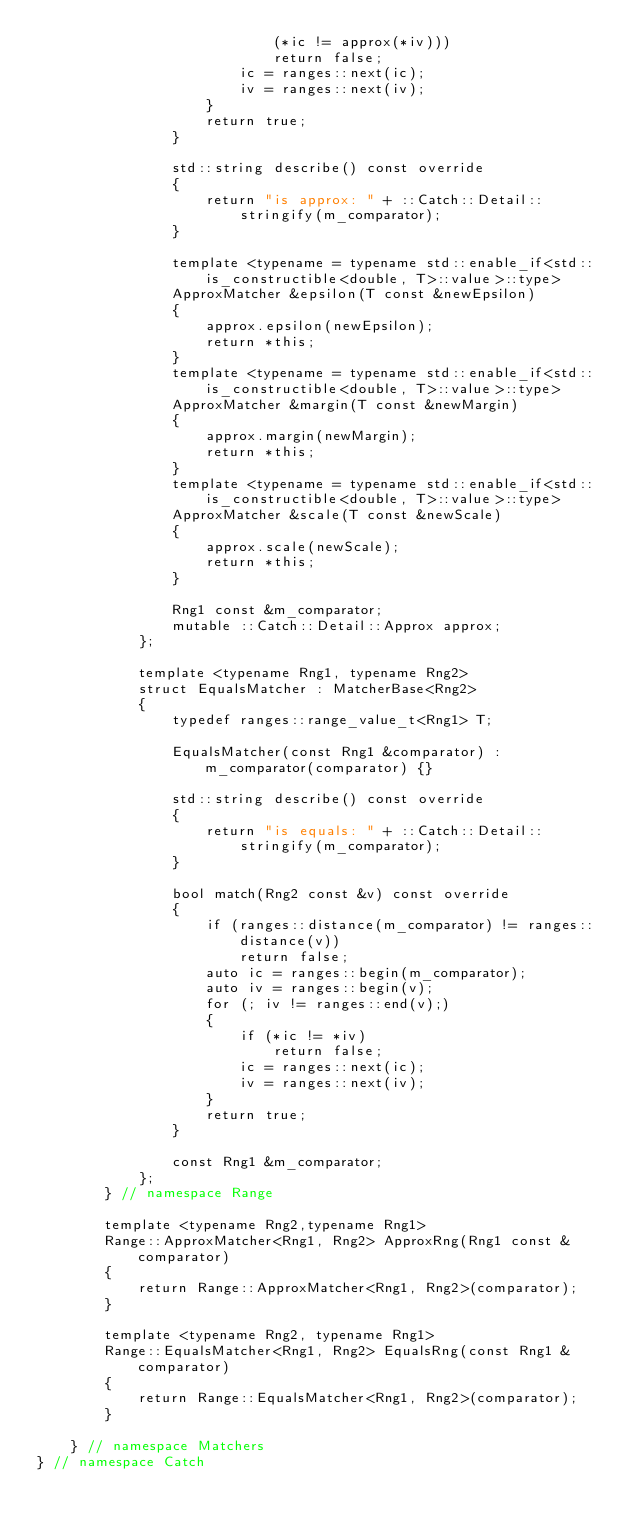Convert code to text. <code><loc_0><loc_0><loc_500><loc_500><_C++_>                            (*ic != approx(*iv)))
                            return false;
                        ic = ranges::next(ic);
                        iv = ranges::next(iv);
                    }
                    return true;
                }

                std::string describe() const override
                {
                    return "is approx: " + ::Catch::Detail::stringify(m_comparator);
                }

                template <typename = typename std::enable_if<std::is_constructible<double, T>::value>::type>
                ApproxMatcher &epsilon(T const &newEpsilon)
                {
                    approx.epsilon(newEpsilon);
                    return *this;
                }
                template <typename = typename std::enable_if<std::is_constructible<double, T>::value>::type>
                ApproxMatcher &margin(T const &newMargin)
                {
                    approx.margin(newMargin);
                    return *this;
                }
                template <typename = typename std::enable_if<std::is_constructible<double, T>::value>::type>
                ApproxMatcher &scale(T const &newScale)
                {
                    approx.scale(newScale);
                    return *this;
                }

                Rng1 const &m_comparator;
                mutable ::Catch::Detail::Approx approx;
            };

            template <typename Rng1, typename Rng2>
            struct EqualsMatcher : MatcherBase<Rng2>
            {
                typedef ranges::range_value_t<Rng1> T;

                EqualsMatcher(const Rng1 &comparator) : m_comparator(comparator) {}

                std::string describe() const override
                {
                    return "is equals: " + ::Catch::Detail::stringify(m_comparator);
                }

                bool match(Rng2 const &v) const override
                {
                    if (ranges::distance(m_comparator) != ranges::distance(v))
                        return false;
                    auto ic = ranges::begin(m_comparator);
                    auto iv = ranges::begin(v);
                    for (; iv != ranges::end(v);)
                    {
                        if (*ic != *iv)
                            return false;
                        ic = ranges::next(ic);
                        iv = ranges::next(iv);
                    }
                    return true;
                }

                const Rng1 &m_comparator;
            };
        } // namespace Range

        template <typename Rng2,typename Rng1>
        Range::ApproxMatcher<Rng1, Rng2> ApproxRng(Rng1 const &comparator)
        {
            return Range::ApproxMatcher<Rng1, Rng2>(comparator);
        }

        template <typename Rng2, typename Rng1>
        Range::EqualsMatcher<Rng1, Rng2> EqualsRng(const Rng1 &comparator)
        {
            return Range::EqualsMatcher<Rng1, Rng2>(comparator);
        }

    } // namespace Matchers
} // namespace Catch</code> 